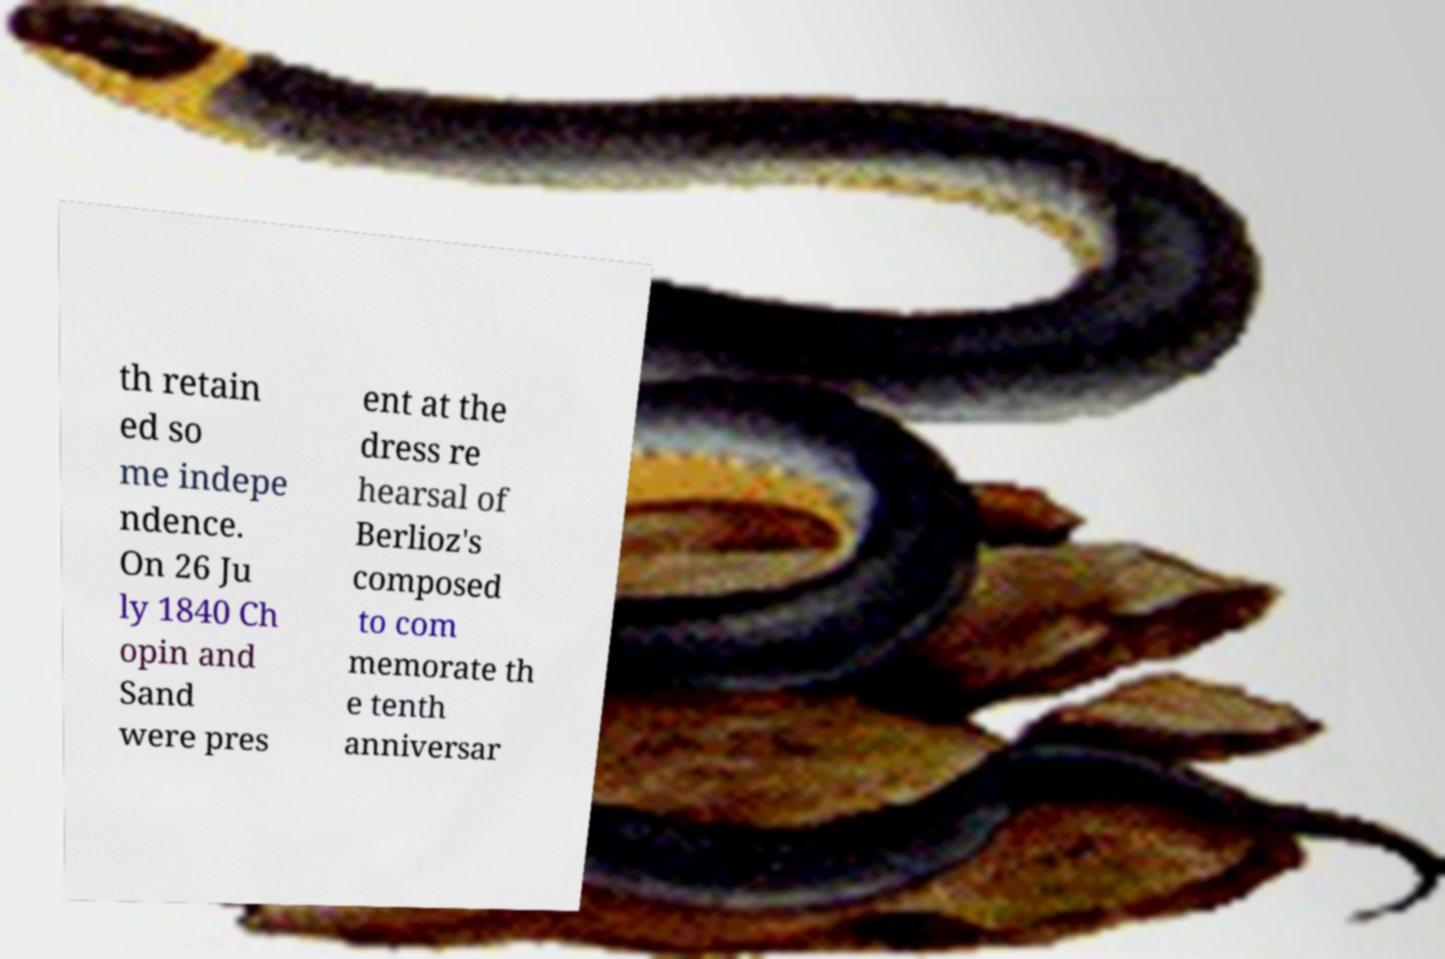For documentation purposes, I need the text within this image transcribed. Could you provide that? th retain ed so me indepe ndence. On 26 Ju ly 1840 Ch opin and Sand were pres ent at the dress re hearsal of Berlioz's composed to com memorate th e tenth anniversar 